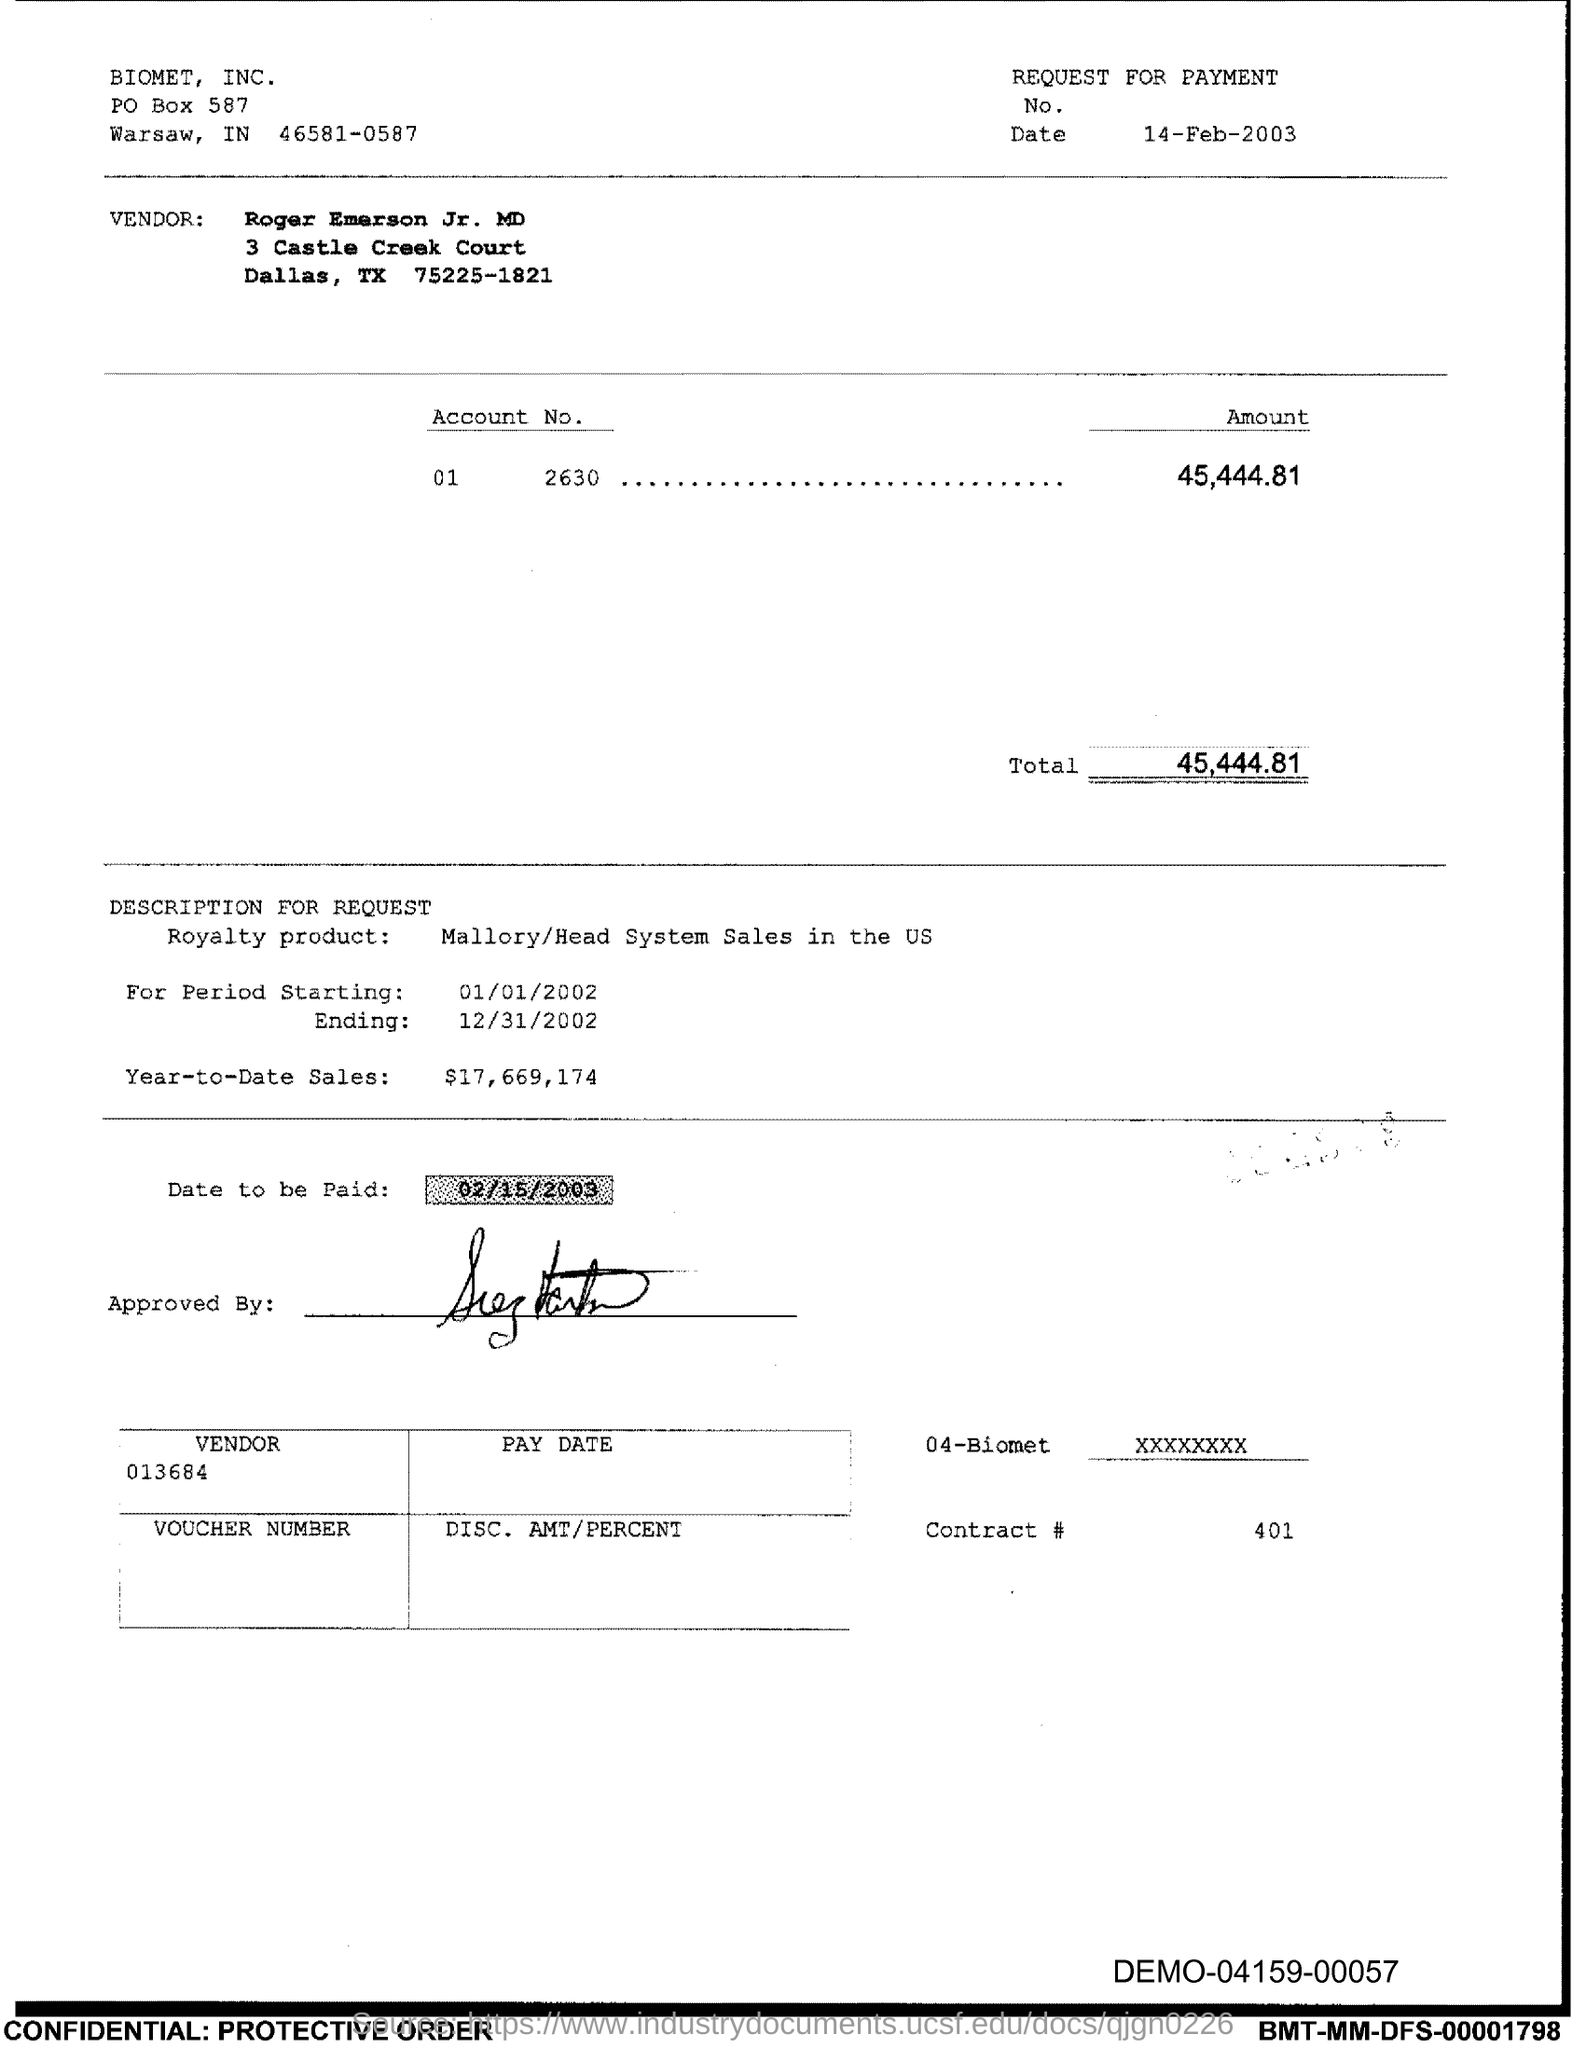What is the year-to-date sales amount specified on this request? The year-to-date sales amount indicated on the request for payment is $17,669,174, as seen in the section titled 'DESCRIPTION FOR REQUEST.' 